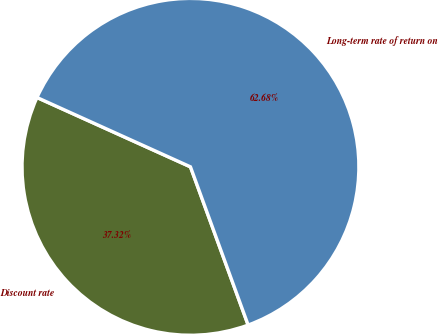<chart> <loc_0><loc_0><loc_500><loc_500><pie_chart><fcel>Discount rate<fcel>Long-term rate of return on<nl><fcel>37.32%<fcel>62.68%<nl></chart> 